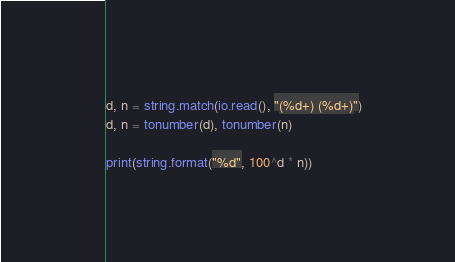<code> <loc_0><loc_0><loc_500><loc_500><_Lua_>d, n = string.match(io.read(), "(%d+) (%d+)")
d, n = tonumber(d), tonumber(n)

print(string.format("%d", 100^d * n))
</code> 